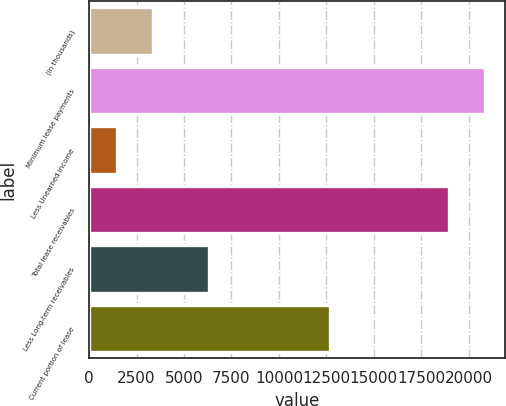Convert chart to OTSL. <chart><loc_0><loc_0><loc_500><loc_500><bar_chart><fcel>(In thousands)<fcel>Minimum lease payments<fcel>Less Unearned income<fcel>Total lease receivables<fcel>Less Long-term receivables<fcel>Current portion of lease<nl><fcel>3344.8<fcel>20875.8<fcel>1447<fcel>18978<fcel>6297<fcel>12681<nl></chart> 